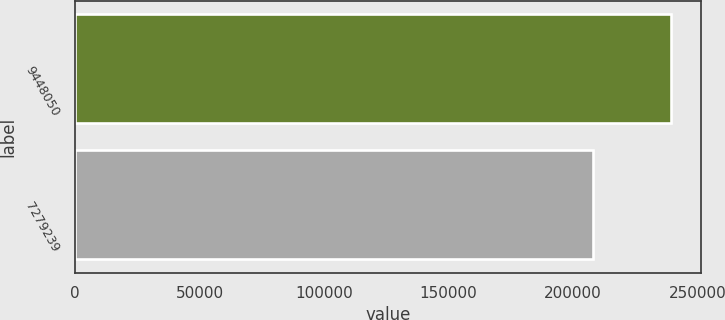Convert chart. <chart><loc_0><loc_0><loc_500><loc_500><bar_chart><fcel>9448050<fcel>7279239<nl><fcel>239342<fcel>207939<nl></chart> 